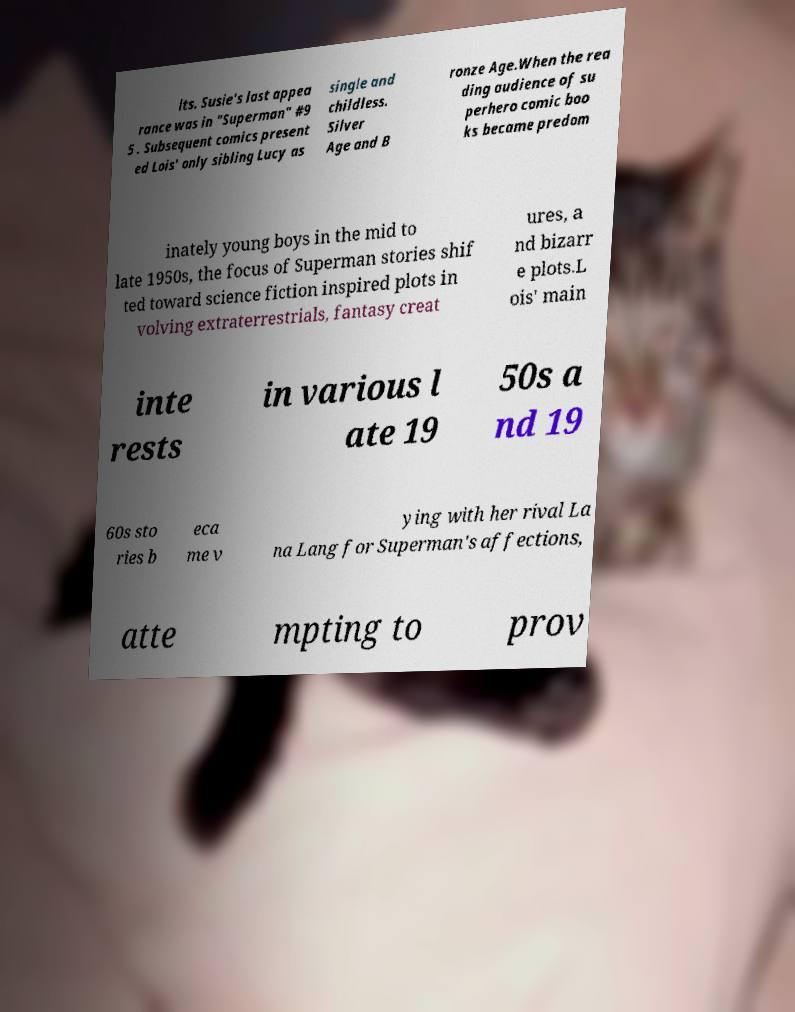For documentation purposes, I need the text within this image transcribed. Could you provide that? lts. Susie's last appea rance was in "Superman" #9 5 . Subsequent comics present ed Lois' only sibling Lucy as single and childless. Silver Age and B ronze Age.When the rea ding audience of su perhero comic boo ks became predom inately young boys in the mid to late 1950s, the focus of Superman stories shif ted toward science fiction inspired plots in volving extraterrestrials, fantasy creat ures, a nd bizarr e plots.L ois' main inte rests in various l ate 19 50s a nd 19 60s sto ries b eca me v ying with her rival La na Lang for Superman's affections, atte mpting to prov 